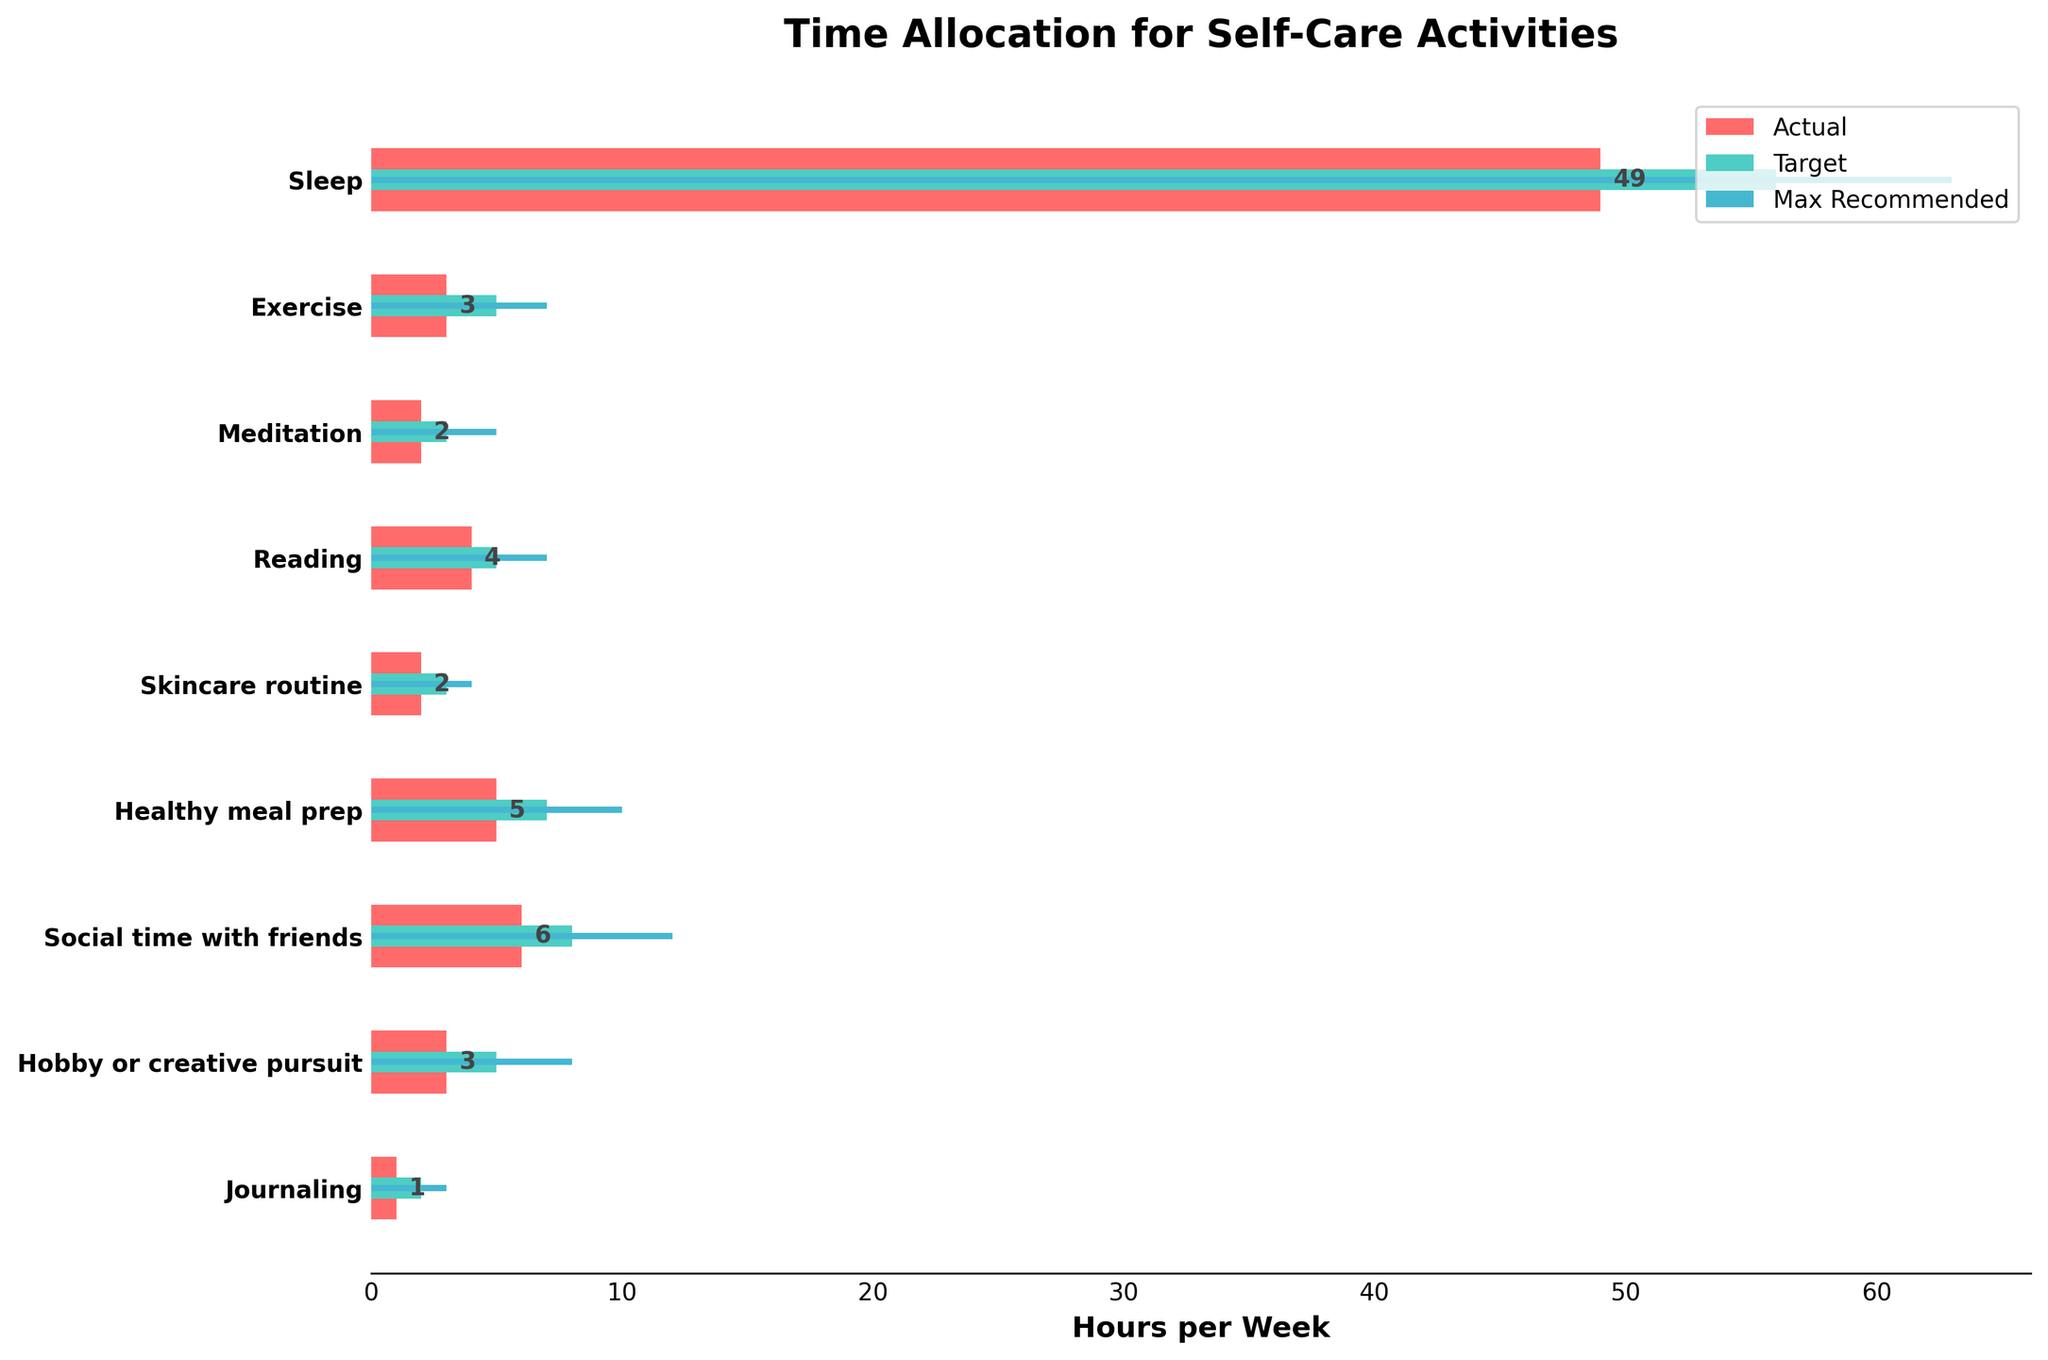what is the title of the figure? The title is usually located at the top of the figure. In this case, it should describe the main topic or data being presented.
Answer: Time Allocation for Self-Care Activities how many activities are being tracked in the figure? Each activity is represented by a horizontal bar in the figure. Count the number of bars.
Answer: 9 which self-care activity has the highest target hours? Locate the green bars representing target hours and identify the one that extends the furthest to the right.
Answer: Sleep by how many hours do you exceed the target for "Social time with friends"? Compare the actual hours bar (red) and the target hours bar (green) for "Social time with friends", then calculate the difference: Actual - Target.
Answer: -2 hours which activity falls short of its maximum recommended hours by the greatest amount? Compare the difference between the actual hours (red) and maximum recommended hours (blue) for all activities. Identify the greatest shortfall.
Answer: Healthy meal prep what is the sum of actual hours spent on "Exercise" and "Meditation"? Add the actual hours for "Exercise" and "Meditation" together (3 + 2).
Answer: 5 hours which activity has the smallest discrepancy between actual hours and target hours? Find the difference between the actual and target hours for each activity, and identify the smallest value.
Answer: Hobby or creative pursuit which activity meets the target hours exactly? Compare the length of the actual hours bar (red) to the target hours bar (green). If they match perfectly, that activity meets its target hours.
Answer: None how many hours of journaling are recommended compared to the actual? Look at the recommended (target) hours and actual hours bars for journaling, and identify their lengths. Compare the two values directly.
Answer: Recommended: 2 hours, Actual: 1 hour 